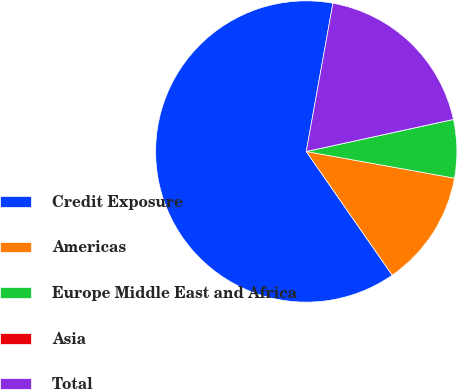Convert chart. <chart><loc_0><loc_0><loc_500><loc_500><pie_chart><fcel>Credit Exposure<fcel>Americas<fcel>Europe Middle East and Africa<fcel>Asia<fcel>Total<nl><fcel>62.49%<fcel>12.5%<fcel>6.25%<fcel>0.0%<fcel>18.75%<nl></chart> 